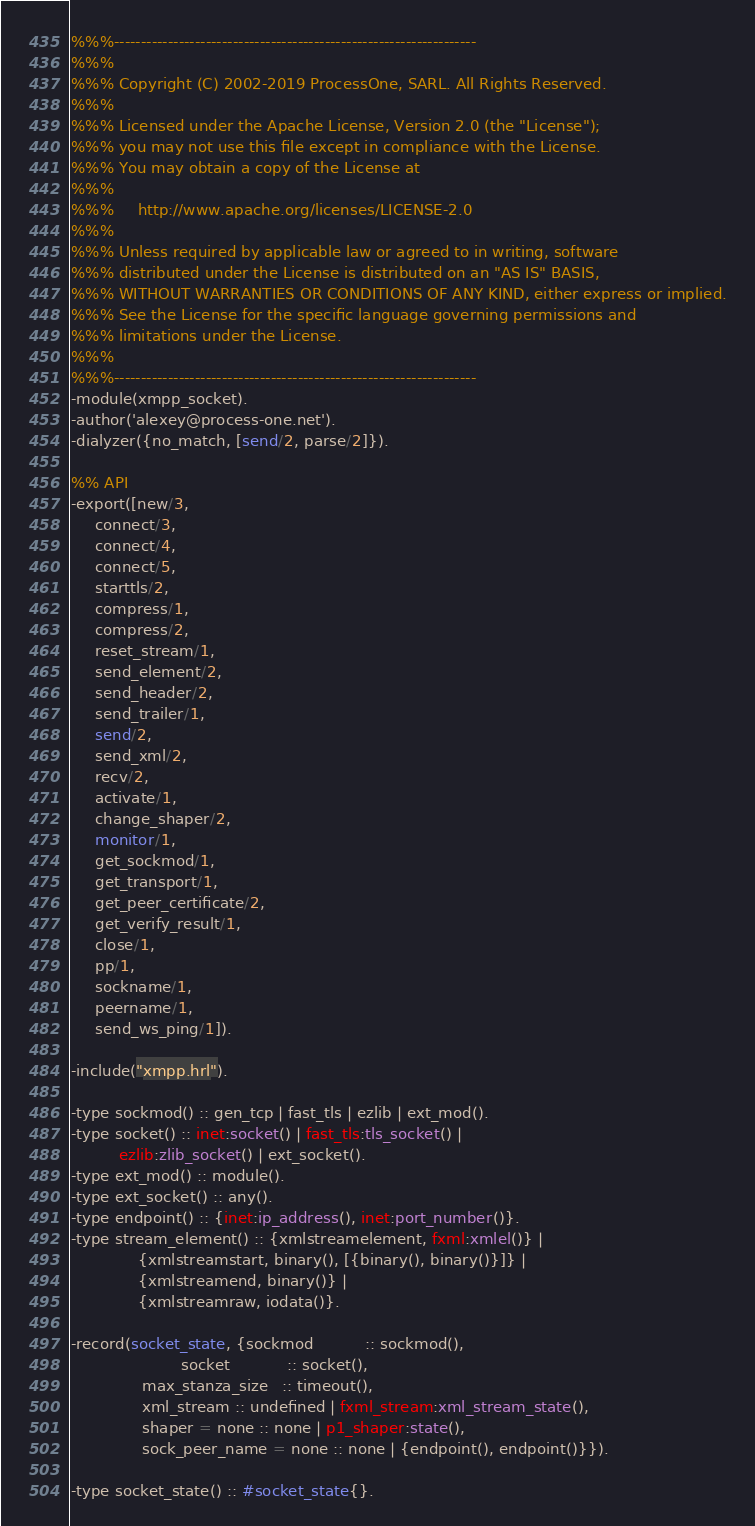Convert code to text. <code><loc_0><loc_0><loc_500><loc_500><_Erlang_>%%%-------------------------------------------------------------------
%%%
%%% Copyright (C) 2002-2019 ProcessOne, SARL. All Rights Reserved.
%%%
%%% Licensed under the Apache License, Version 2.0 (the "License");
%%% you may not use this file except in compliance with the License.
%%% You may obtain a copy of the License at
%%%
%%%     http://www.apache.org/licenses/LICENSE-2.0
%%%
%%% Unless required by applicable law or agreed to in writing, software
%%% distributed under the License is distributed on an "AS IS" BASIS,
%%% WITHOUT WARRANTIES OR CONDITIONS OF ANY KIND, either express or implied.
%%% See the License for the specific language governing permissions and
%%% limitations under the License.
%%%
%%%-------------------------------------------------------------------
-module(xmpp_socket).
-author('alexey@process-one.net').
-dialyzer({no_match, [send/2, parse/2]}).

%% API
-export([new/3,
	 connect/3,
	 connect/4,
	 connect/5,
	 starttls/2,
	 compress/1,
	 compress/2,
	 reset_stream/1,
	 send_element/2,
	 send_header/2,
	 send_trailer/1,
	 send/2,
	 send_xml/2,
	 recv/2,
	 activate/1,
	 change_shaper/2,
	 monitor/1,
	 get_sockmod/1,
	 get_transport/1,
	 get_peer_certificate/2,
	 get_verify_result/1,
	 close/1,
	 pp/1,
	 sockname/1,
	 peername/1,
	 send_ws_ping/1]).

-include("xmpp.hrl").

-type sockmod() :: gen_tcp | fast_tls | ezlib | ext_mod().
-type socket() :: inet:socket() | fast_tls:tls_socket() |
		  ezlib:zlib_socket() | ext_socket().
-type ext_mod() :: module().
-type ext_socket() :: any().
-type endpoint() :: {inet:ip_address(), inet:port_number()}.
-type stream_element() :: {xmlstreamelement, fxml:xmlel()} |
			  {xmlstreamstart, binary(), [{binary(), binary()}]} |
			  {xmlstreamend, binary()} |
			  {xmlstreamraw, iodata()}.

-record(socket_state, {sockmod           :: sockmod(),
                       socket            :: socket(),
		       max_stanza_size   :: timeout(),
		       xml_stream :: undefined | fxml_stream:xml_stream_state(),
		       shaper = none :: none | p1_shaper:state(),
		       sock_peer_name = none :: none | {endpoint(), endpoint()}}).

-type socket_state() :: #socket_state{}.
</code> 